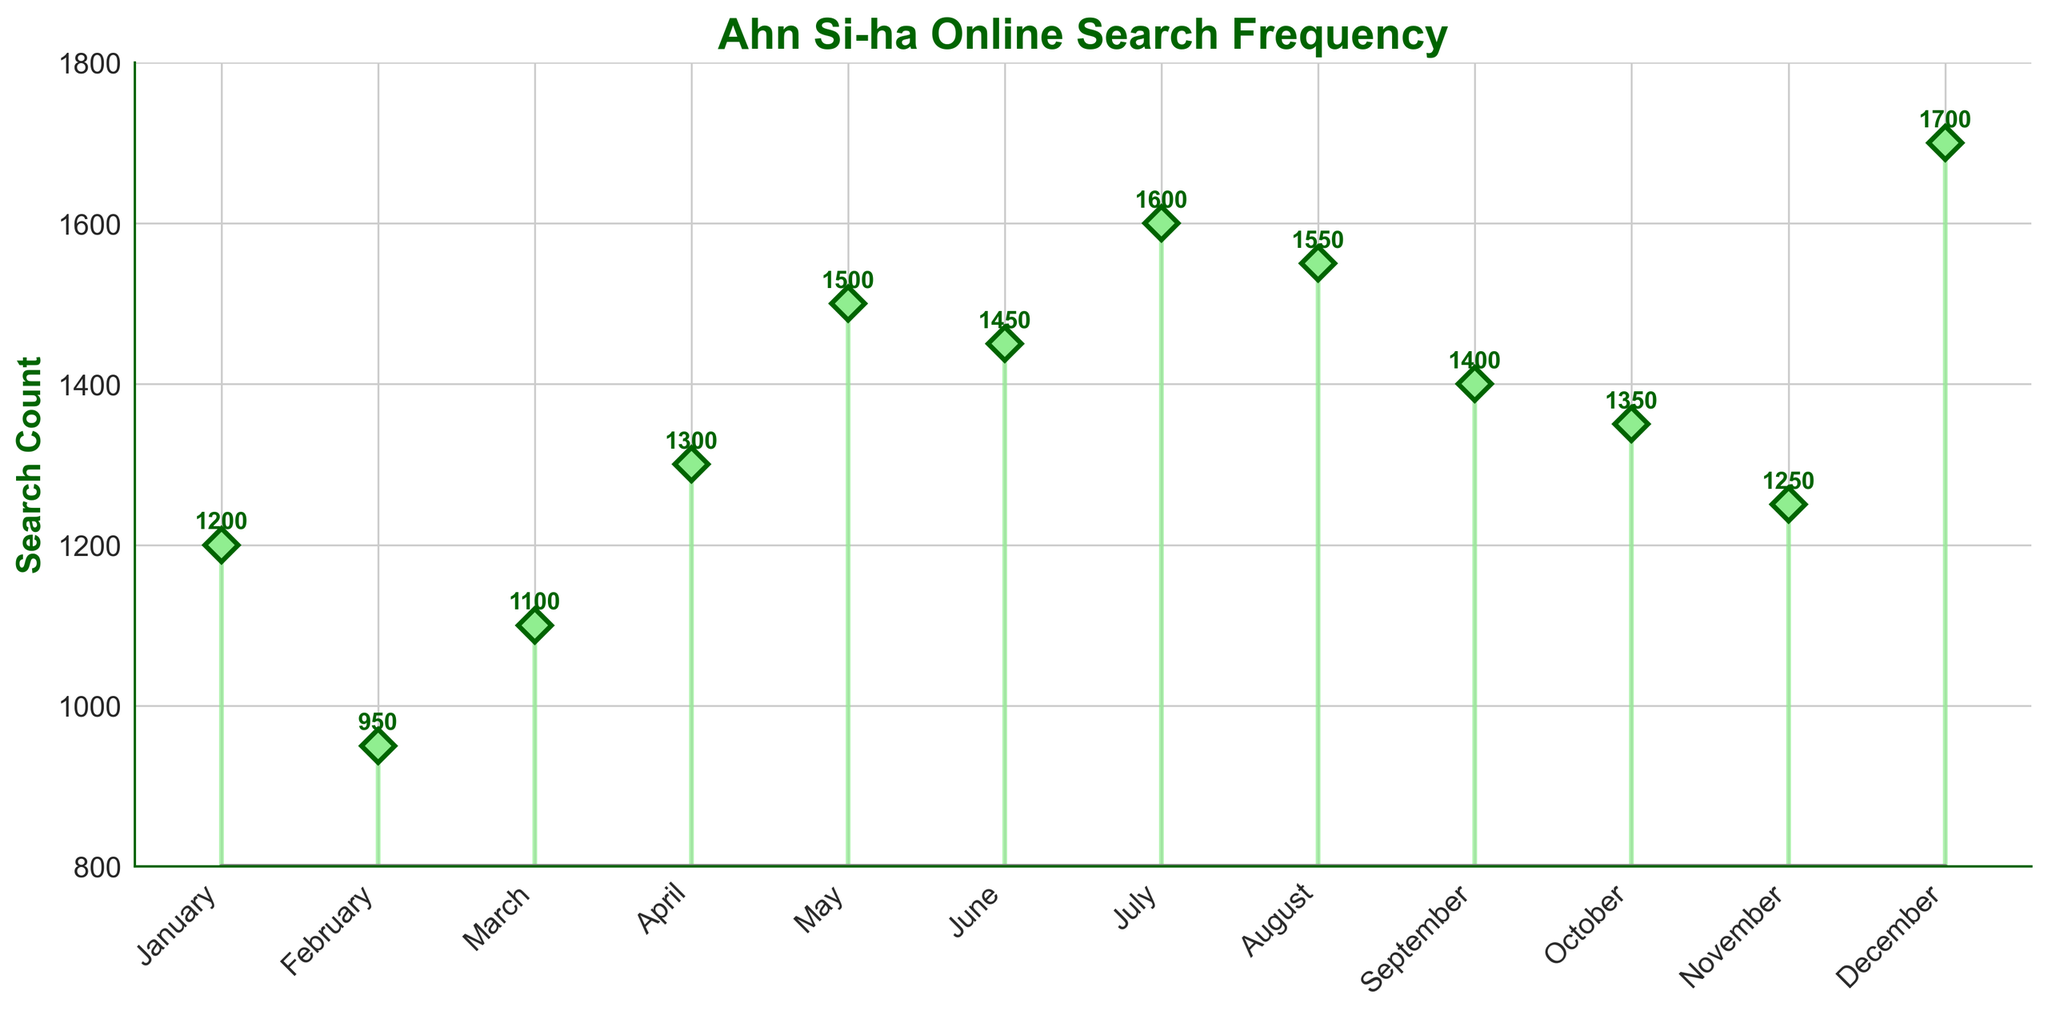What is the title of the figure? The title is usually located at the top of the figure and summarizes what the chart is about. In this case, it reads "Ahn Si-ha Online Search Frequency."
Answer: Ahn Si-ha Online Search Frequency Which month has the highest search count? By looking at the stem plot, we can see that December has the highest search count as its stem reaches the highest point.
Answer: December How many data points are plotted? Each month of the year has a corresponding stem, so there are 12 data points in total. January through December are plotted.
Answer: 12 What is the search count for July? Locate the stem for July and note the annotated number next to it. The search count for July is indicated as 1600.
Answer: 1600 Which month shows a search count lower than 1000? By observing the plot, only February has a stem that does not reach above 1000 with an annotated number of 950.
Answer: February Compare the search trends between June and September. Which month has more searches? By looking at the stems for June and September, we see that June has a count of 1450 and September has a count of 1400, so June has more searches than September.
Answer: June What is the difference in search count between May and November? The search counts for May and November are 1500 and 1250 respectively. Subtracting these values, we get 1500 - 1250 = 250.
Answer: 250 Identify two months with an identical search count trend pattern. Check for months with close or equal stem lengths. April and October have counts of 1300 and 1350 respectively, displaying a similar trend.
Answer: April and October What is the average search count over the year? Sum all the search counts and divide by 12: (1200 + 950 + 1100 + 1300 + 1500 + 1450 + 1600 + 1550 + 1400 + 1350 + 1250 + 1700) / 12 = 15050 / 12 ≈ 1254.17
Answer: 1254.17 Why might December have the highest search count compared to other months? December shows the highest count possibly due to end-of-year nostalgia, holiday searches, or specific events related to Ahn Si-ha during that month. This is a hypothesized reasoning based on typical trends and events in December.
Answer: End-of-year events or holiday searches 